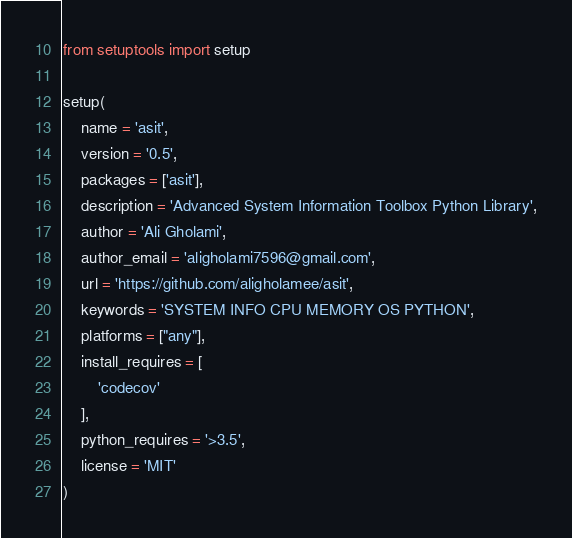<code> <loc_0><loc_0><loc_500><loc_500><_Python_>from setuptools import setup

setup(
    name = 'asit',
    version = '0.5',
    packages = ['asit'],
    description = 'Advanced System Information Toolbox Python Library',
    author = 'Ali Gholami', 
    author_email = 'aligholami7596@gmail.com',
    url = 'https://github.com/aligholamee/asit',
    keywords = 'SYSTEM INFO CPU MEMORY OS PYTHON',
    platforms = ["any"],
    install_requires = [
        'codecov'
    ],
    python_requires = '>3.5',
    license = 'MIT'
)
</code> 